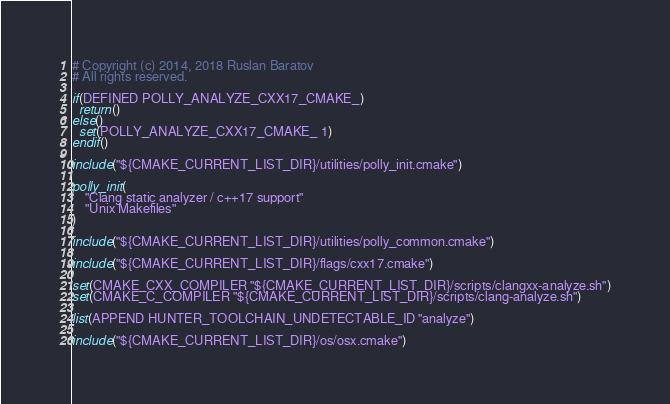Convert code to text. <code><loc_0><loc_0><loc_500><loc_500><_CMake_># Copyright (c) 2014, 2018 Ruslan Baratov
# All rights reserved.

if(DEFINED POLLY_ANALYZE_CXX17_CMAKE_)
  return()
else()
  set(POLLY_ANALYZE_CXX17_CMAKE_ 1)
endif()

include("${CMAKE_CURRENT_LIST_DIR}/utilities/polly_init.cmake")

polly_init(
    "Clang static analyzer / c++17 support"
    "Unix Makefiles"
)

include("${CMAKE_CURRENT_LIST_DIR}/utilities/polly_common.cmake")

include("${CMAKE_CURRENT_LIST_DIR}/flags/cxx17.cmake")

set(CMAKE_CXX_COMPILER "${CMAKE_CURRENT_LIST_DIR}/scripts/clangxx-analyze.sh")
set(CMAKE_C_COMPILER "${CMAKE_CURRENT_LIST_DIR}/scripts/clang-analyze.sh")

list(APPEND HUNTER_TOOLCHAIN_UNDETECTABLE_ID "analyze")

include("${CMAKE_CURRENT_LIST_DIR}/os/osx.cmake")
</code> 